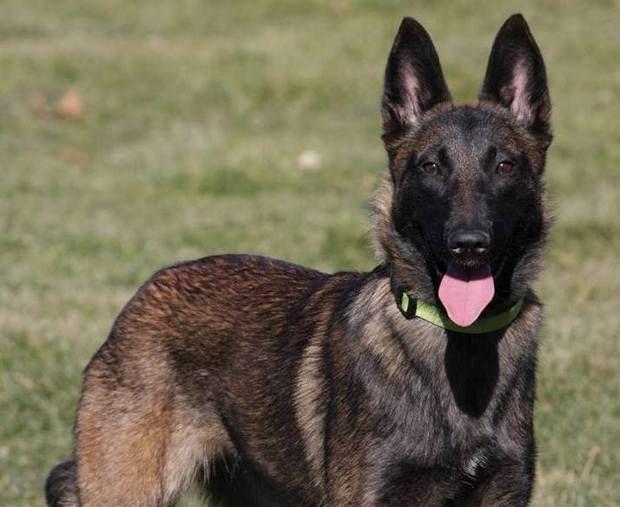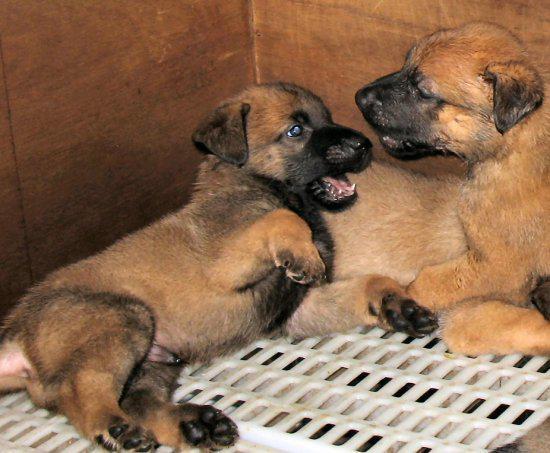The first image is the image on the left, the second image is the image on the right. Considering the images on both sides, is "Only german shepherd puppies are shown, and each image includes at least two puppies." valid? Answer yes or no. No. The first image is the image on the left, the second image is the image on the right. Assess this claim about the two images: "There is no more than one dog in the left image.". Correct or not? Answer yes or no. Yes. 